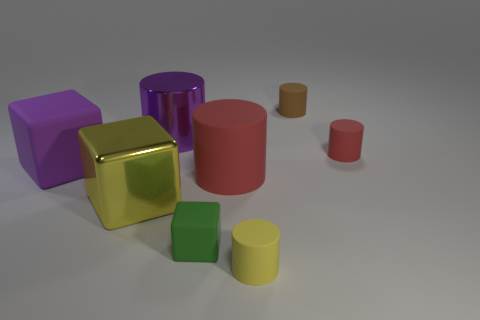Subtract 2 cylinders. How many cylinders are left? 3 Subtract all blue cylinders. Subtract all blue balls. How many cylinders are left? 5 Add 2 yellow cylinders. How many objects exist? 10 Subtract all cylinders. How many objects are left? 3 Add 7 big purple cylinders. How many big purple cylinders are left? 8 Add 4 small yellow rubber things. How many small yellow rubber things exist? 5 Subtract 0 brown balls. How many objects are left? 8 Subtract all purple cubes. Subtract all large cylinders. How many objects are left? 5 